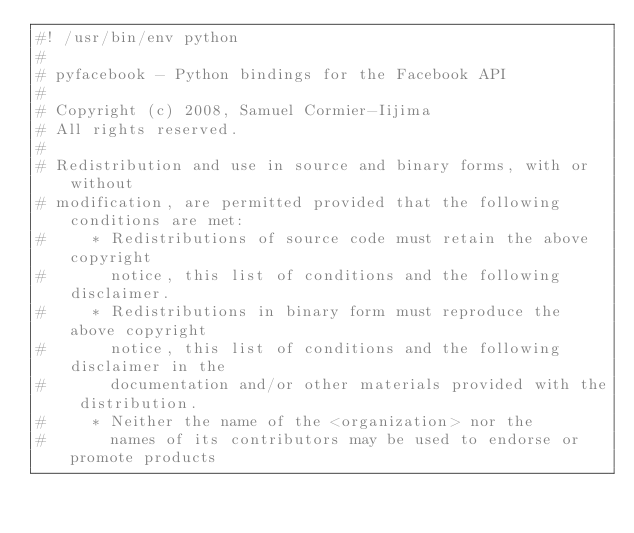Convert code to text. <code><loc_0><loc_0><loc_500><loc_500><_Python_>#! /usr/bin/env python
#
# pyfacebook - Python bindings for the Facebook API
#
# Copyright (c) 2008, Samuel Cormier-Iijima
# All rights reserved.
#
# Redistribution and use in source and binary forms, with or without
# modification, are permitted provided that the following conditions are met:
#     * Redistributions of source code must retain the above copyright
#       notice, this list of conditions and the following disclaimer.
#     * Redistributions in binary form must reproduce the above copyright
#       notice, this list of conditions and the following disclaimer in the
#       documentation and/or other materials provided with the distribution.
#     * Neither the name of the <organization> nor the
#       names of its contributors may be used to endorse or promote products</code> 